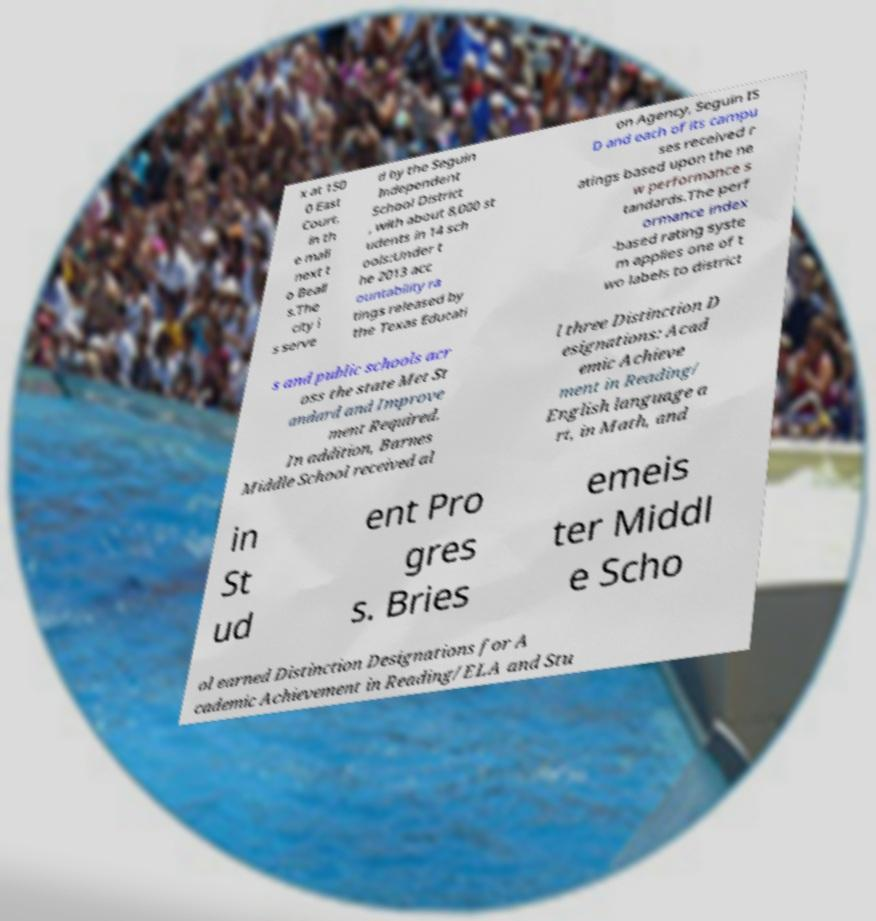Can you accurately transcribe the text from the provided image for me? x at 150 0 East Court, in th e mall next t o Beall s.The city i s serve d by the Seguin Independent School District , with about 8,000 st udents in 14 sch ools:Under t he 2013 acc ountability ra tings released by the Texas Educati on Agency, Seguin IS D and each of its campu ses received r atings based upon the ne w performance s tandards.The perf ormance index -based rating syste m applies one of t wo labels to district s and public schools acr oss the state Met St andard and Improve ment Required. In addition, Barnes Middle School received al l three Distinction D esignations: Acad emic Achieve ment in Reading/ English language a rt, in Math, and in St ud ent Pro gres s. Bries emeis ter Middl e Scho ol earned Distinction Designations for A cademic Achievement in Reading/ELA and Stu 